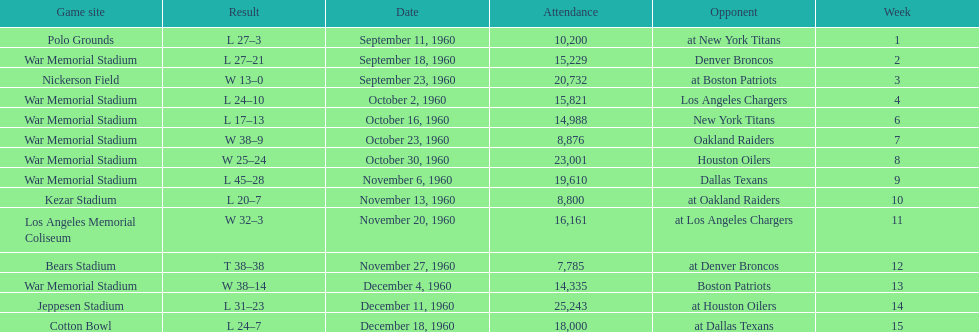How many games had at least 10,000 people in attendance? 11. 